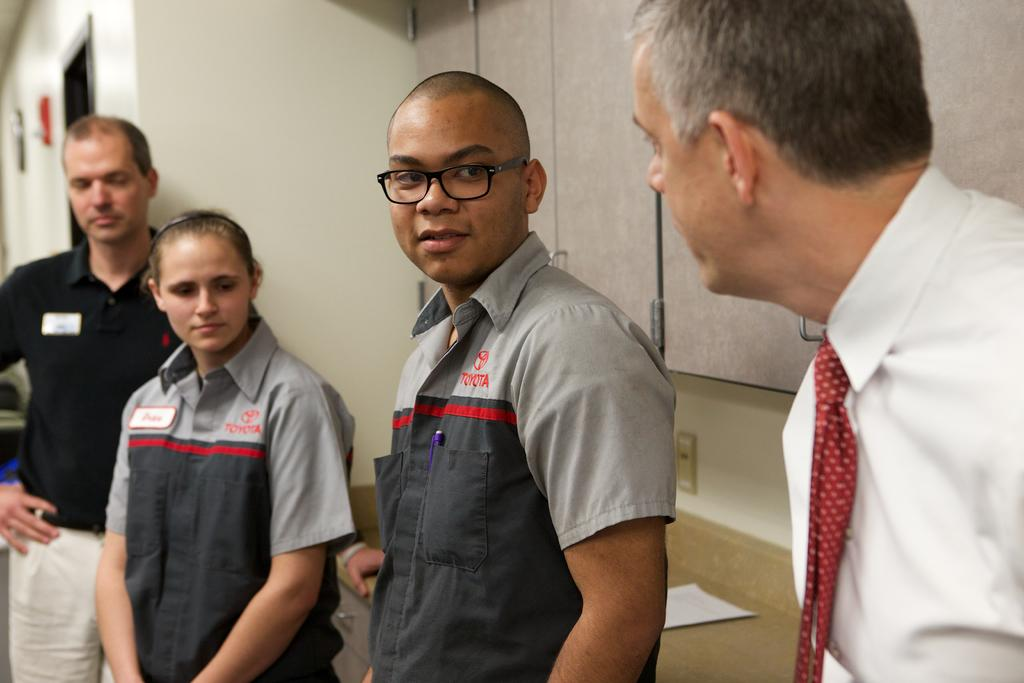How many people are present in the image? There are four people in the image. What are the people doing in the image? The people are standing in the image. What are the people looking at in the image? The people are looking at something, but the specific object or subject cannot be determined from the provided facts. What type of pipe can be seen in the image? There is no pipe present in the image. Is there any dirt visible in the image? The provided facts do not mention any dirt in the image. Can you see any coal in the image? The provided facts do not mention any coal in the image. 